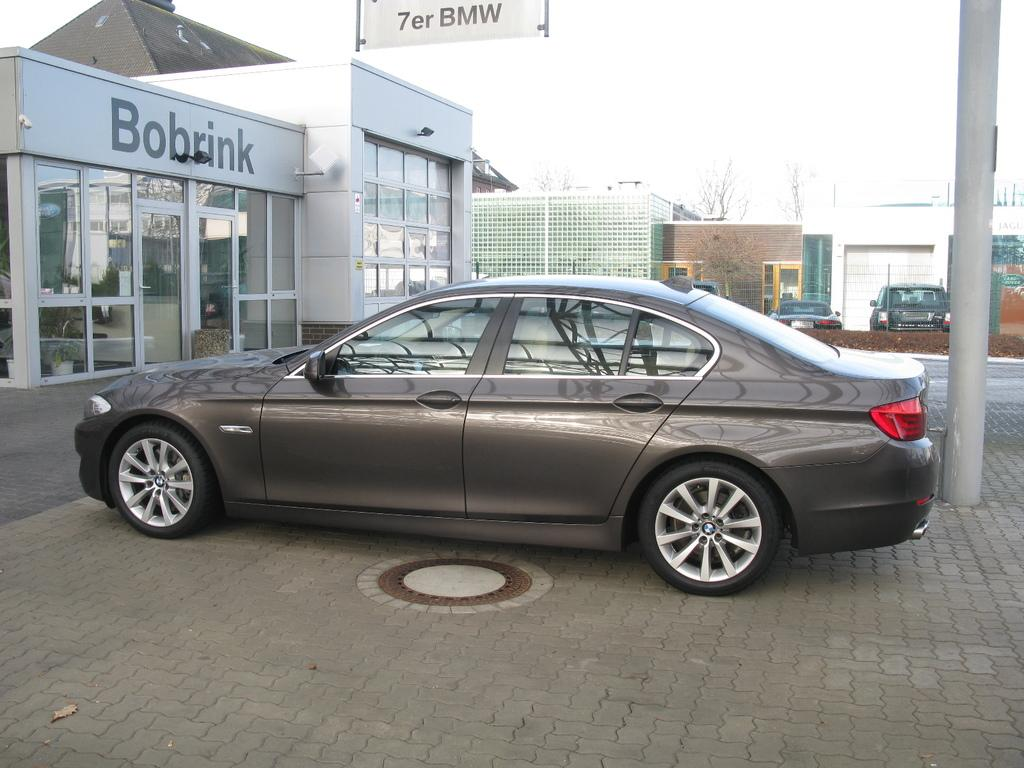What is the main subject in the center of the image? There is a car in the center of the image. What can be seen in the background of the image? There are buildings, trees, and cars in the background of the image. Can you describe the pole on the right side of the image? There is a pole on the right side of the image. What type of disease is affecting the yarn in the image? There is no yarn present in the image, so it is not possible to determine if any disease is affecting it. 